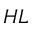<formula> <loc_0><loc_0><loc_500><loc_500>H L</formula> 